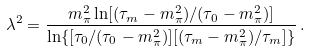Convert formula to latex. <formula><loc_0><loc_0><loc_500><loc_500>\lambda ^ { 2 } = \frac { m ^ { 2 } _ { \pi } \ln [ ( \tau _ { m } - m ^ { 2 } _ { \pi } ) / ( \tau _ { 0 } - m ^ { 2 } _ { \pi } ) ] } { \ln \{ [ \tau _ { 0 } / ( \tau _ { 0 } - m ^ { 2 } _ { \pi } ) ] [ ( \tau _ { m } - m ^ { 2 } _ { \pi } ) / \tau _ { m } ] \} } \, .</formula> 